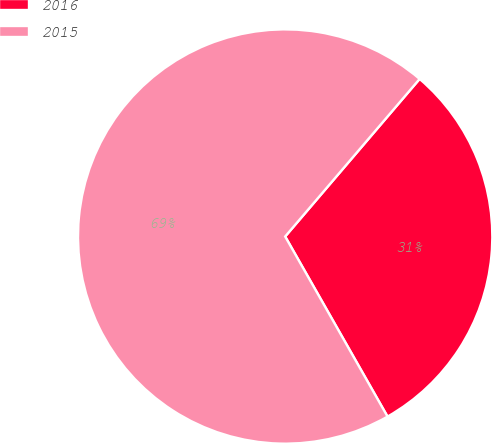Convert chart. <chart><loc_0><loc_0><loc_500><loc_500><pie_chart><fcel>2016<fcel>2015<nl><fcel>30.53%<fcel>69.47%<nl></chart> 